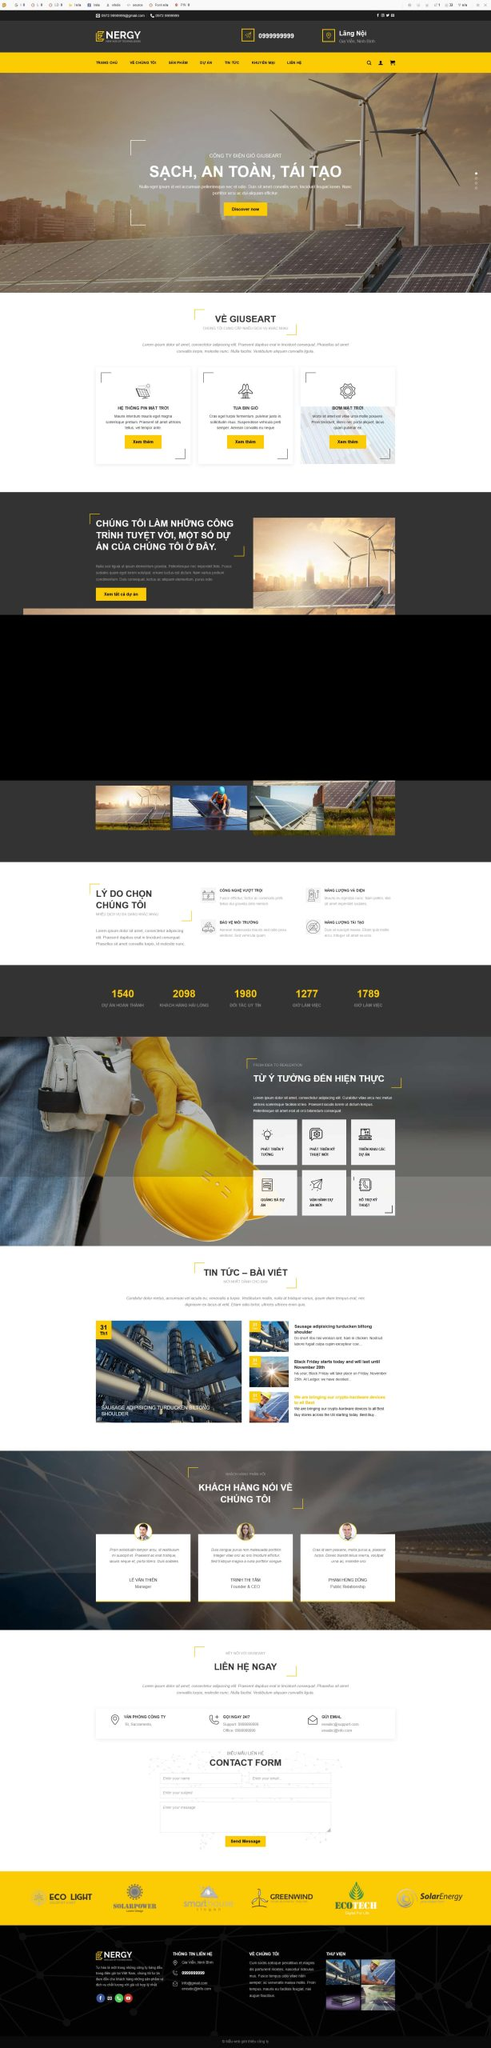Liệt kê 5 ngành nghề, lĩnh vực phù hợp với website này, phân cách các màu sắc bằng dấu phẩy. Chỉ trả về kết quả, phân cách bằng dấy phẩy
 Năng lượng tái tạo, Điện mặt trời, Điện gió, Công nghệ môi trường, Năng lượng sạch 